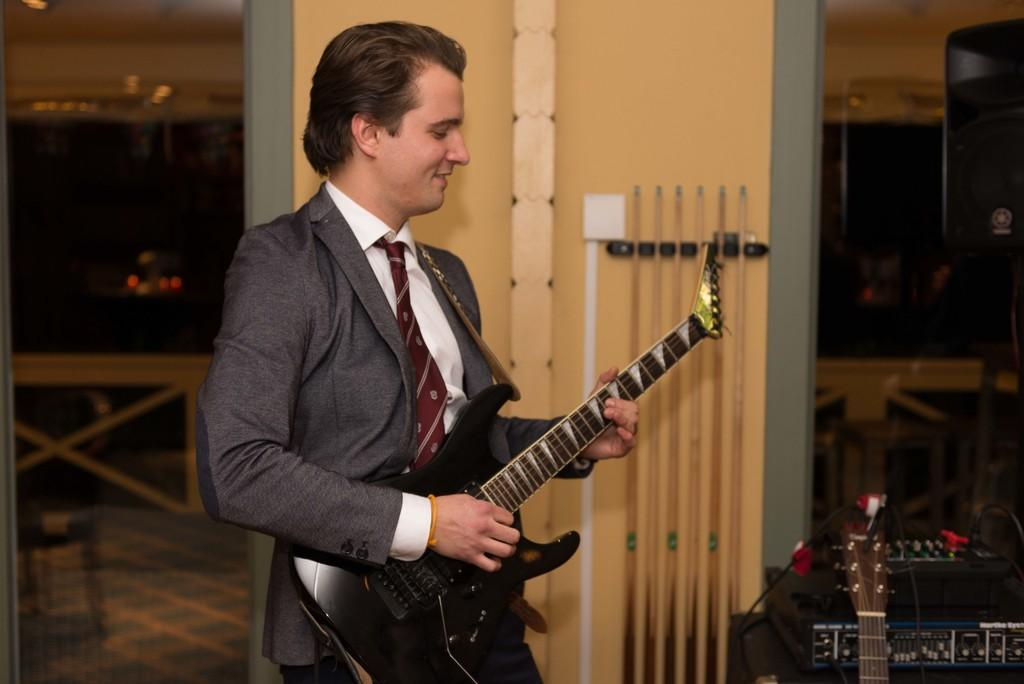What is the man in the image doing? The man is playing a guitar in the image. What is the man's facial expression in the image? The man is smiling in the image. What can be seen in the background of the image? There is a wall and snooker sticks placed in the background of the image. What substance is the man using to play the guitar in the image? The man is not using any substance to play the guitar; he is using his hands to strum the strings. 